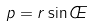Convert formula to latex. <formula><loc_0><loc_0><loc_500><loc_500>p = r \sin \phi</formula> 